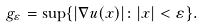Convert formula to latex. <formula><loc_0><loc_0><loc_500><loc_500>g _ { \varepsilon } = \sup \{ | \nabla u ( x ) | \colon | x | < \varepsilon \} .</formula> 